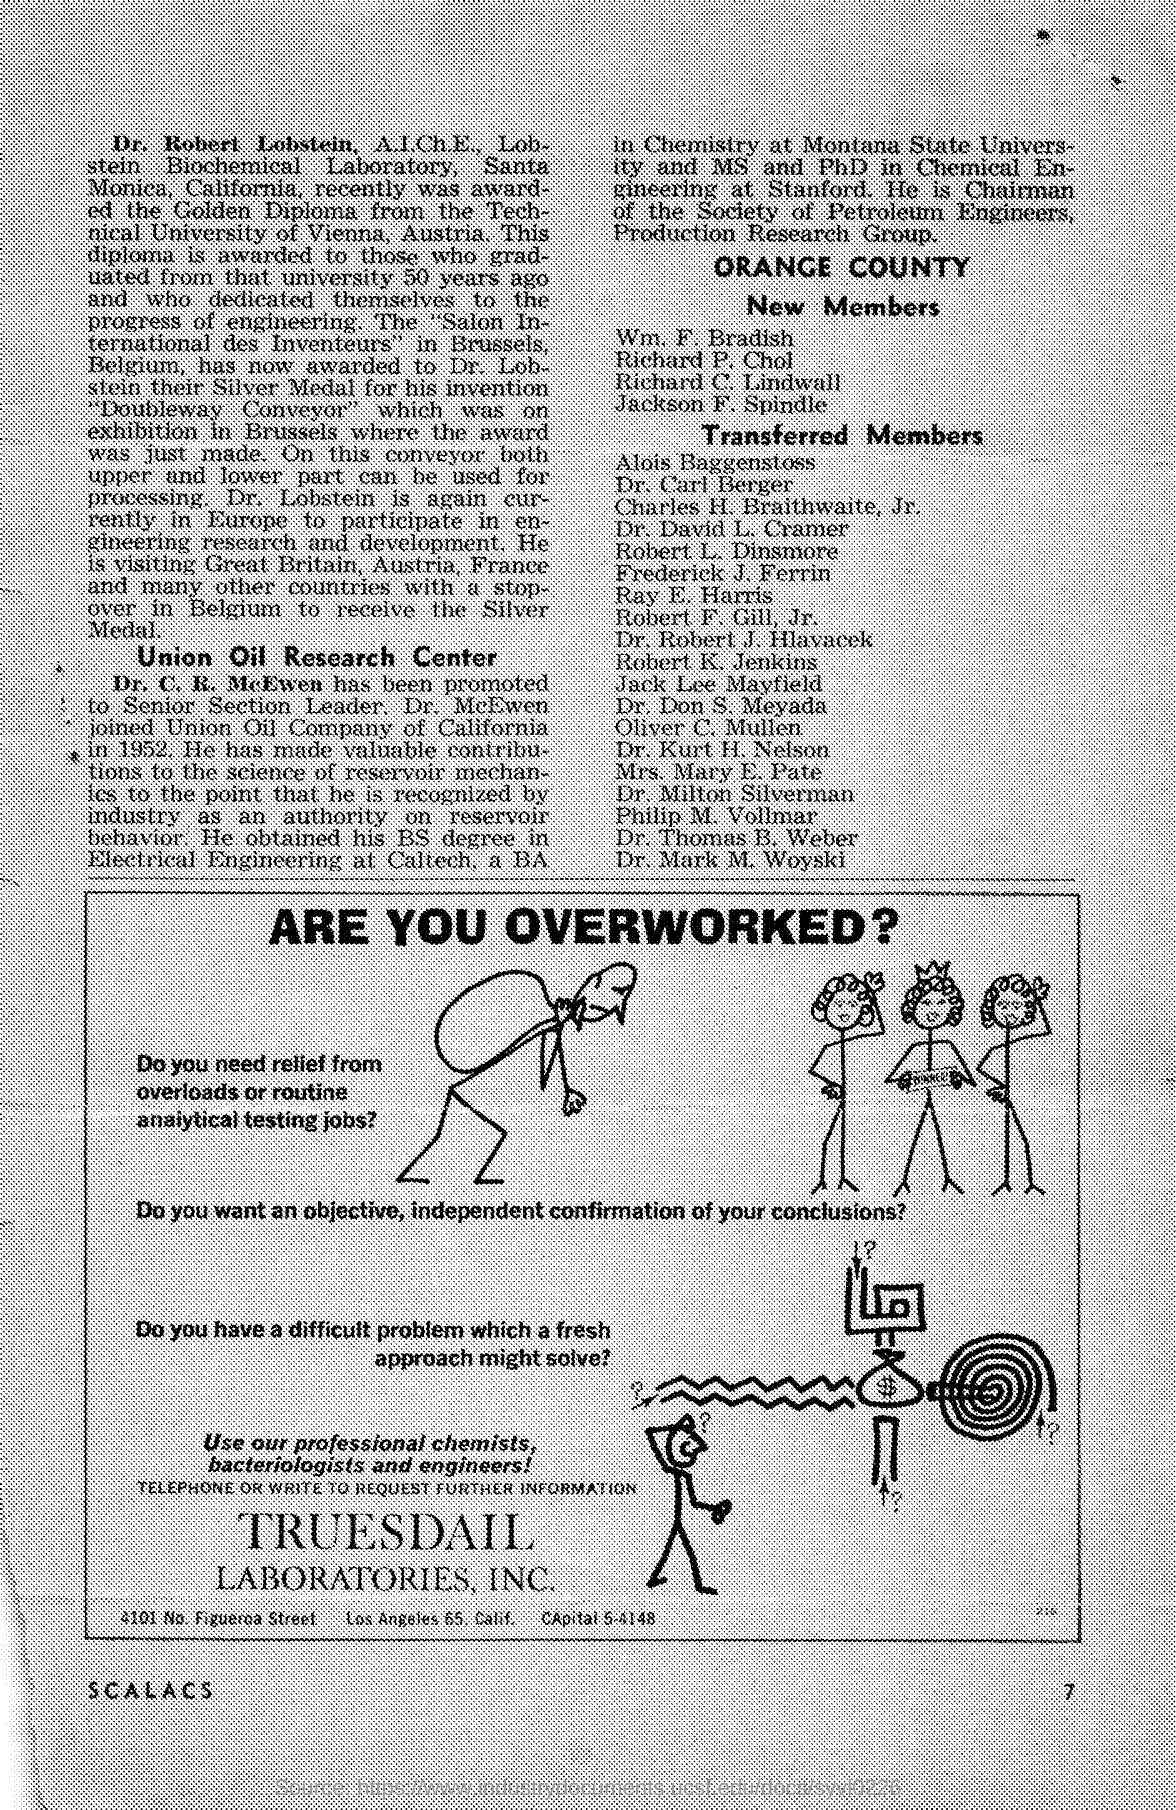List a handful of essential elements in this visual. The name of the laboratories mentioned in the given page is TrueSdail. In 1952, Dr. McEwen joined Union Oil Company of California. 